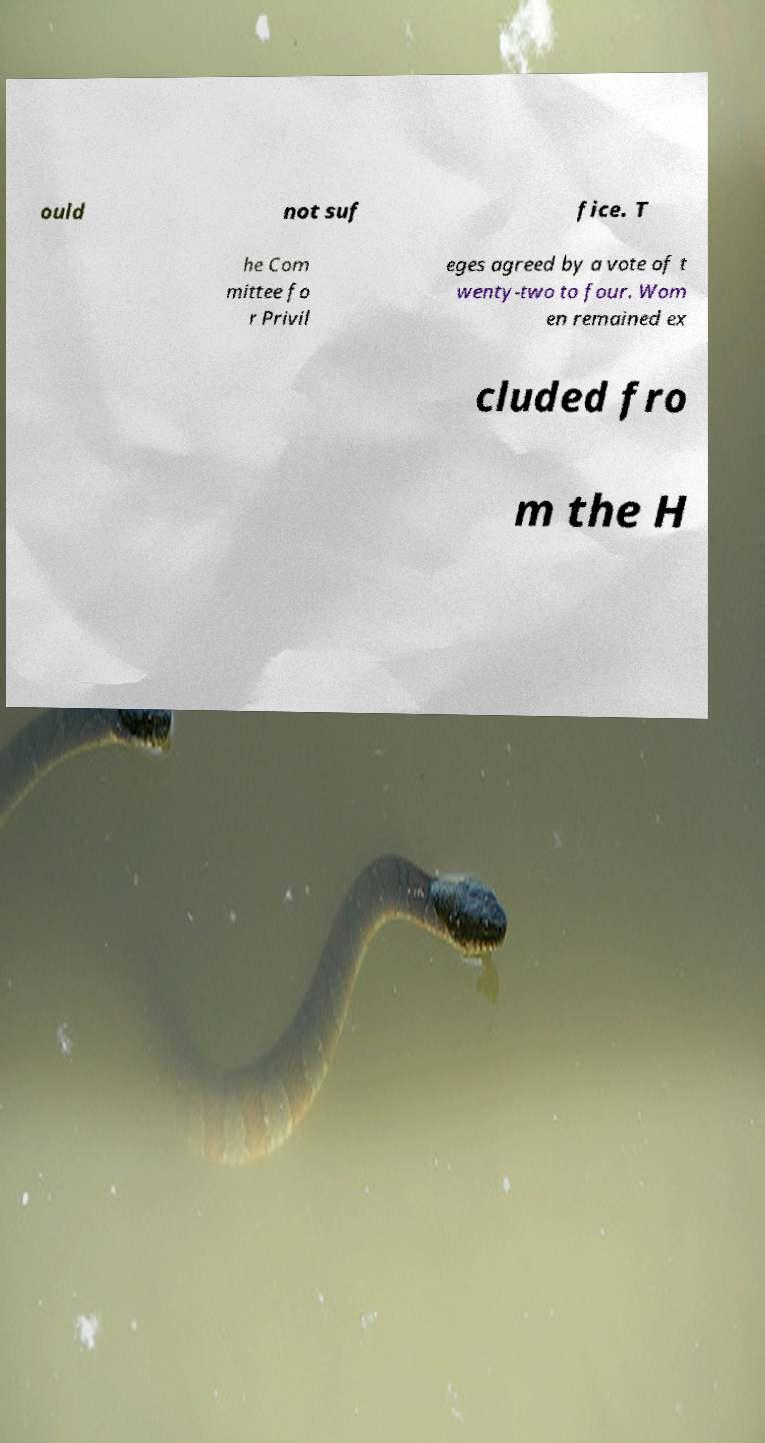Could you assist in decoding the text presented in this image and type it out clearly? ould not suf fice. T he Com mittee fo r Privil eges agreed by a vote of t wenty-two to four. Wom en remained ex cluded fro m the H 